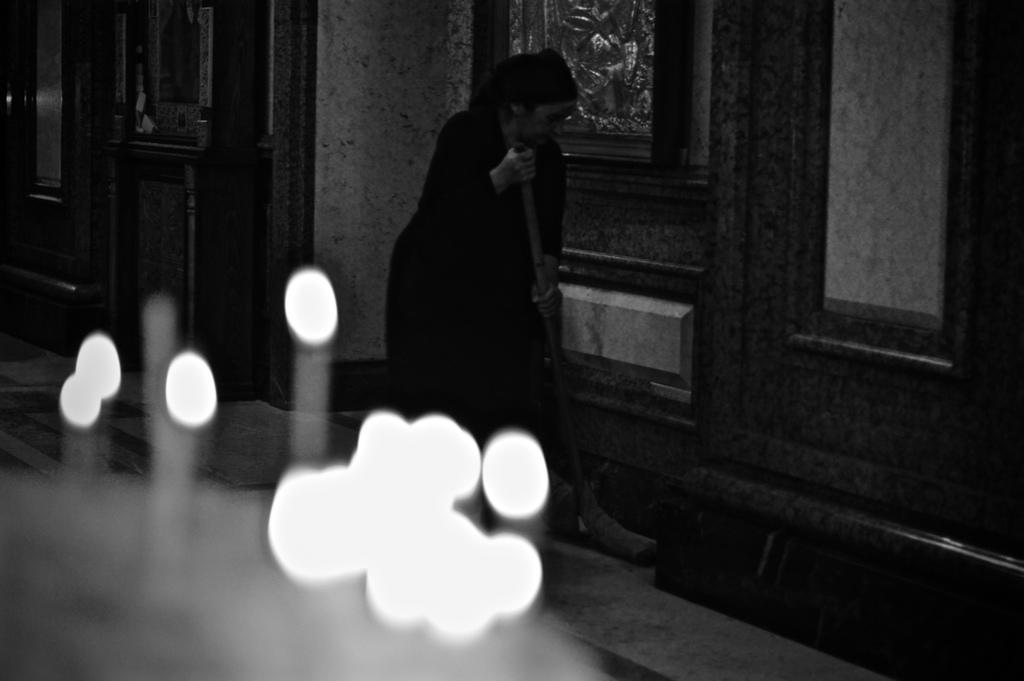Could you give a brief overview of what you see in this image? In this picture we can see a woman holding an object with her hands on the floor, lights and in the background we can see wall. 